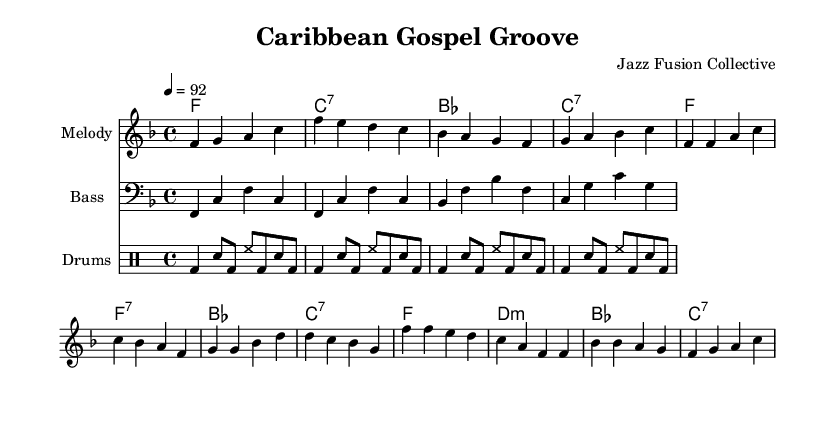What is the key signature of this music? The key signature is indicated at the beginning of the score with a single flat, which corresponds to the key of F major.
Answer: F major What is the time signature of this piece? The time signature is shown at the beginning of the score as a fraction, with a four on top and a four on the bottom, indicating that there are four beats per measure.
Answer: 4/4 What is the tempo marking for this piece? The tempo is noted above the staff as "4 = 92," meaning there are 92 beats per minute, which indicates the speed of the music.
Answer: 92 How many measures are in the intro section? By counting the number of bar lines in the intro part of the melody, we find there are four measures that are marked before the verse begins.
Answer: 4 What kind of rhythmic pattern is used in the drum part? The drum pattern consists of a bass drum, snare, and hi-hat pattern repeated several times which establishes a rhythmic foundation, typical in reggae-influenced music.
Answer: Reggae pattern What is the chord progression for the chorus? By examining the chord symbols under the melody in the chorus section, we see the progression is F major, D minor, B flat major, and C seventh, providing a rich harmonic backdrop.
Answer: F, Dm, B♭, C7 How does the harmony differ between the verse and the chorus? The verse has a mix of major and seventh chords that create a soulful feel, while the chorus features a clearer resolution with a standard major and minor progression that enhances the gospel influence.
Answer: Major and minor chords 